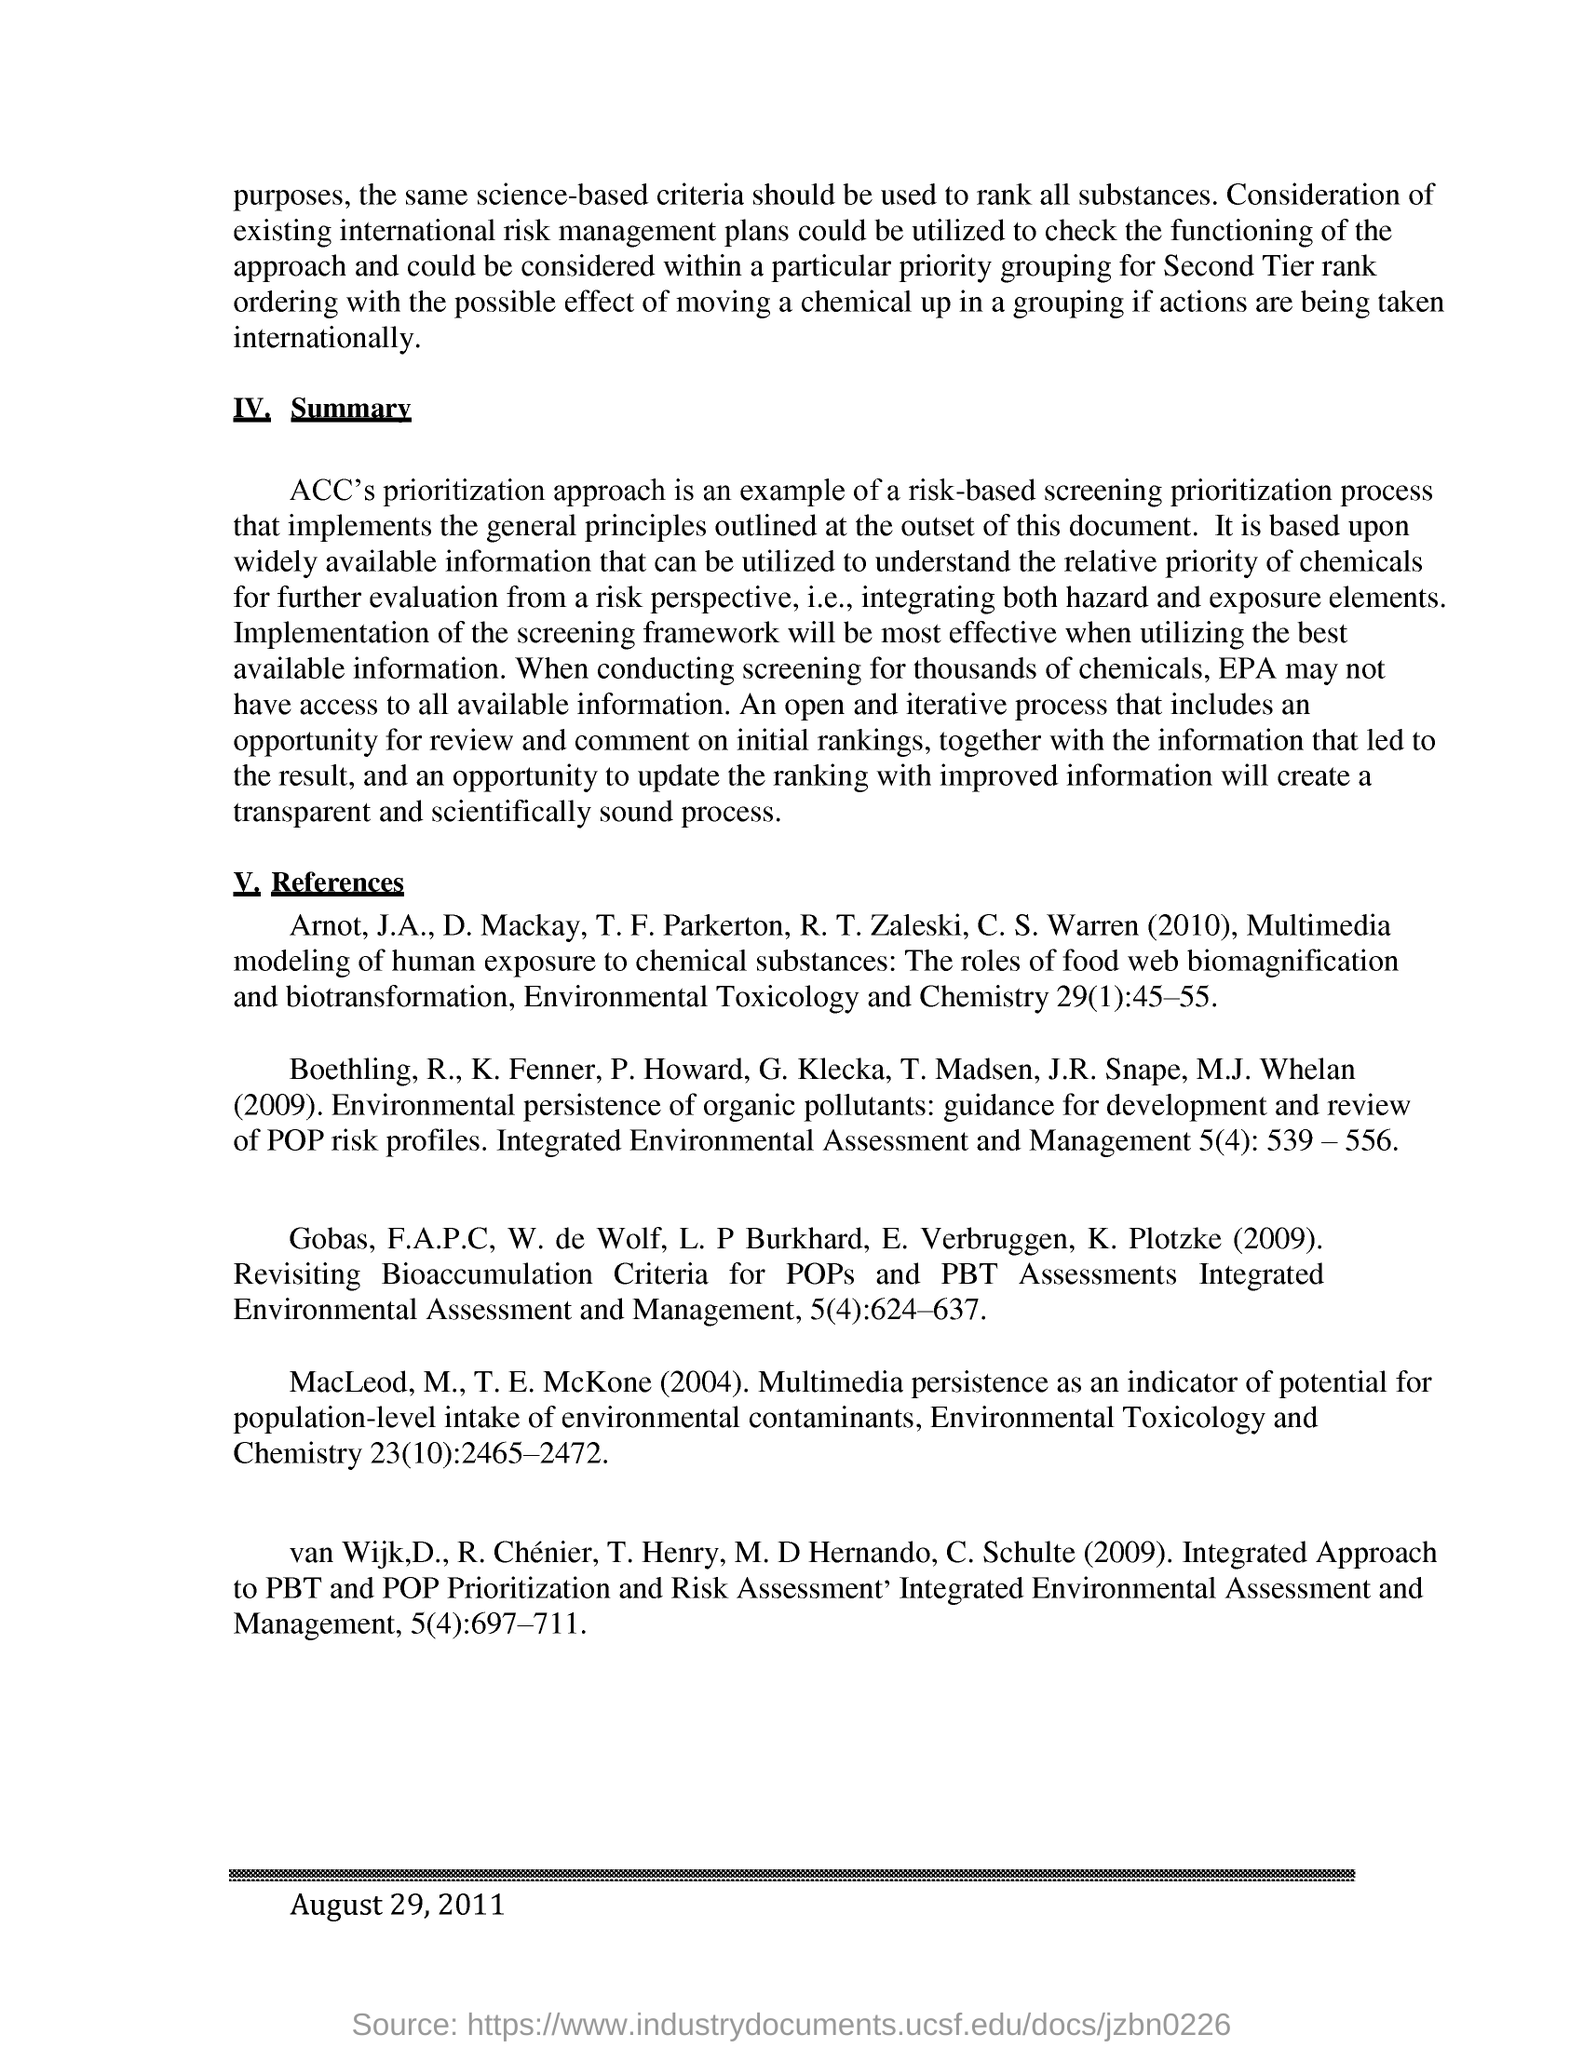When was this information published ?
Keep it short and to the point. August 29, 2011. What is an example for  risk -based screening prioritization process?
Keep it short and to the point. ACC's prioritization approach. When conducting screening for thousands of chemicals, epa may not have access to what ?
Offer a very short reply. To all available information. 